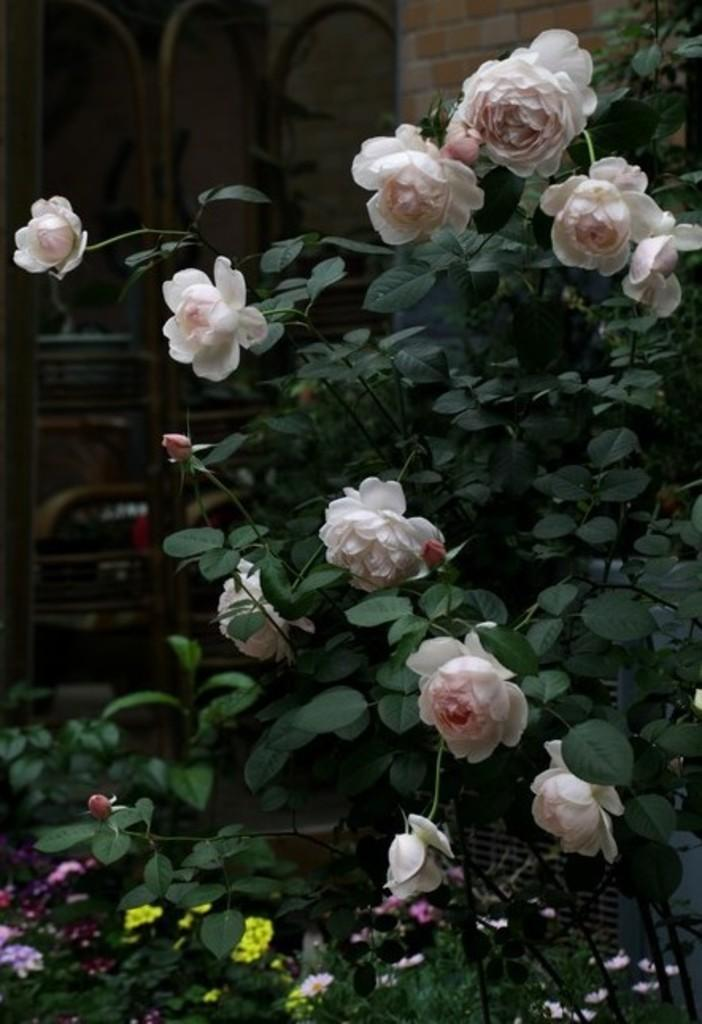What type of flower is present in the image? There is a pink rose flower plant in the image. What can be seen in the background of the image? There is a brick wall and a metal frame grill in the background of the image. How many stars can be seen in the image? There are no stars visible in the image. 